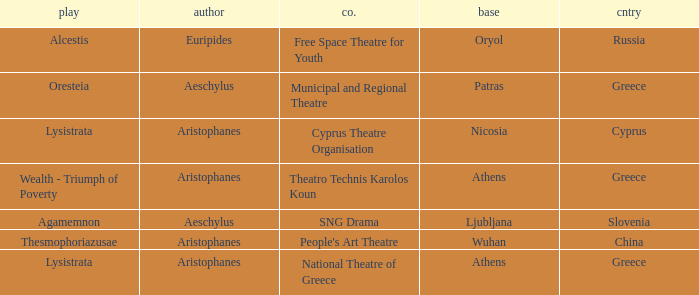What is the company when the country is greece and the author is aeschylus? Municipal and Regional Theatre. Write the full table. {'header': ['play', 'author', 'co.', 'base', 'cntry'], 'rows': [['Alcestis', 'Euripides', 'Free Space Theatre for Youth', 'Oryol', 'Russia'], ['Oresteia', 'Aeschylus', 'Municipal and Regional Theatre', 'Patras', 'Greece'], ['Lysistrata', 'Aristophanes', 'Cyprus Theatre Organisation', 'Nicosia', 'Cyprus'], ['Wealth - Triumph of Poverty', 'Aristophanes', 'Theatro Technis Karolos Koun', 'Athens', 'Greece'], ['Agamemnon', 'Aeschylus', 'SNG Drama', 'Ljubljana', 'Slovenia'], ['Thesmophoriazusae', 'Aristophanes', "People's Art Theatre", 'Wuhan', 'China'], ['Lysistrata', 'Aristophanes', 'National Theatre of Greece', 'Athens', 'Greece']]} 